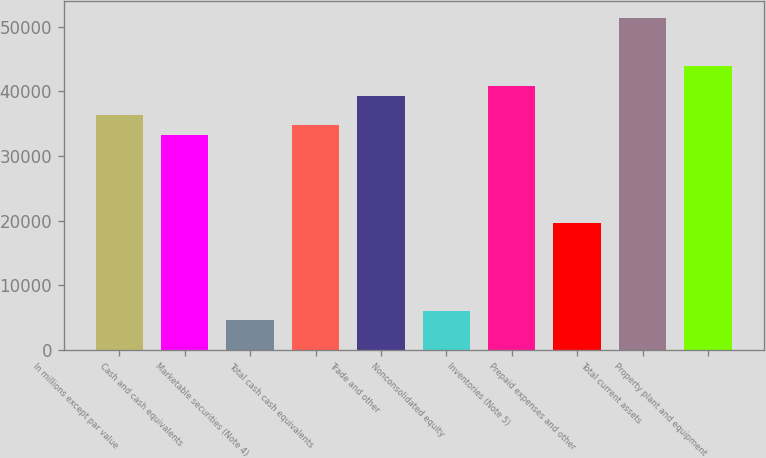Convert chart to OTSL. <chart><loc_0><loc_0><loc_500><loc_500><bar_chart><fcel>In millions except par value<fcel>Cash and cash equivalents<fcel>Marketable securities (Note 4)<fcel>Total cash cash equivalents<fcel>Trade and other<fcel>Nonconsolidated equity<fcel>Inventories (Note 5)<fcel>Prepaid expenses and other<fcel>Total current assets<fcel>Property plant and equipment<nl><fcel>36306.2<fcel>33281.6<fcel>4547.9<fcel>34793.9<fcel>39330.8<fcel>6060.2<fcel>40843.1<fcel>19670.9<fcel>51429.2<fcel>43867.7<nl></chart> 